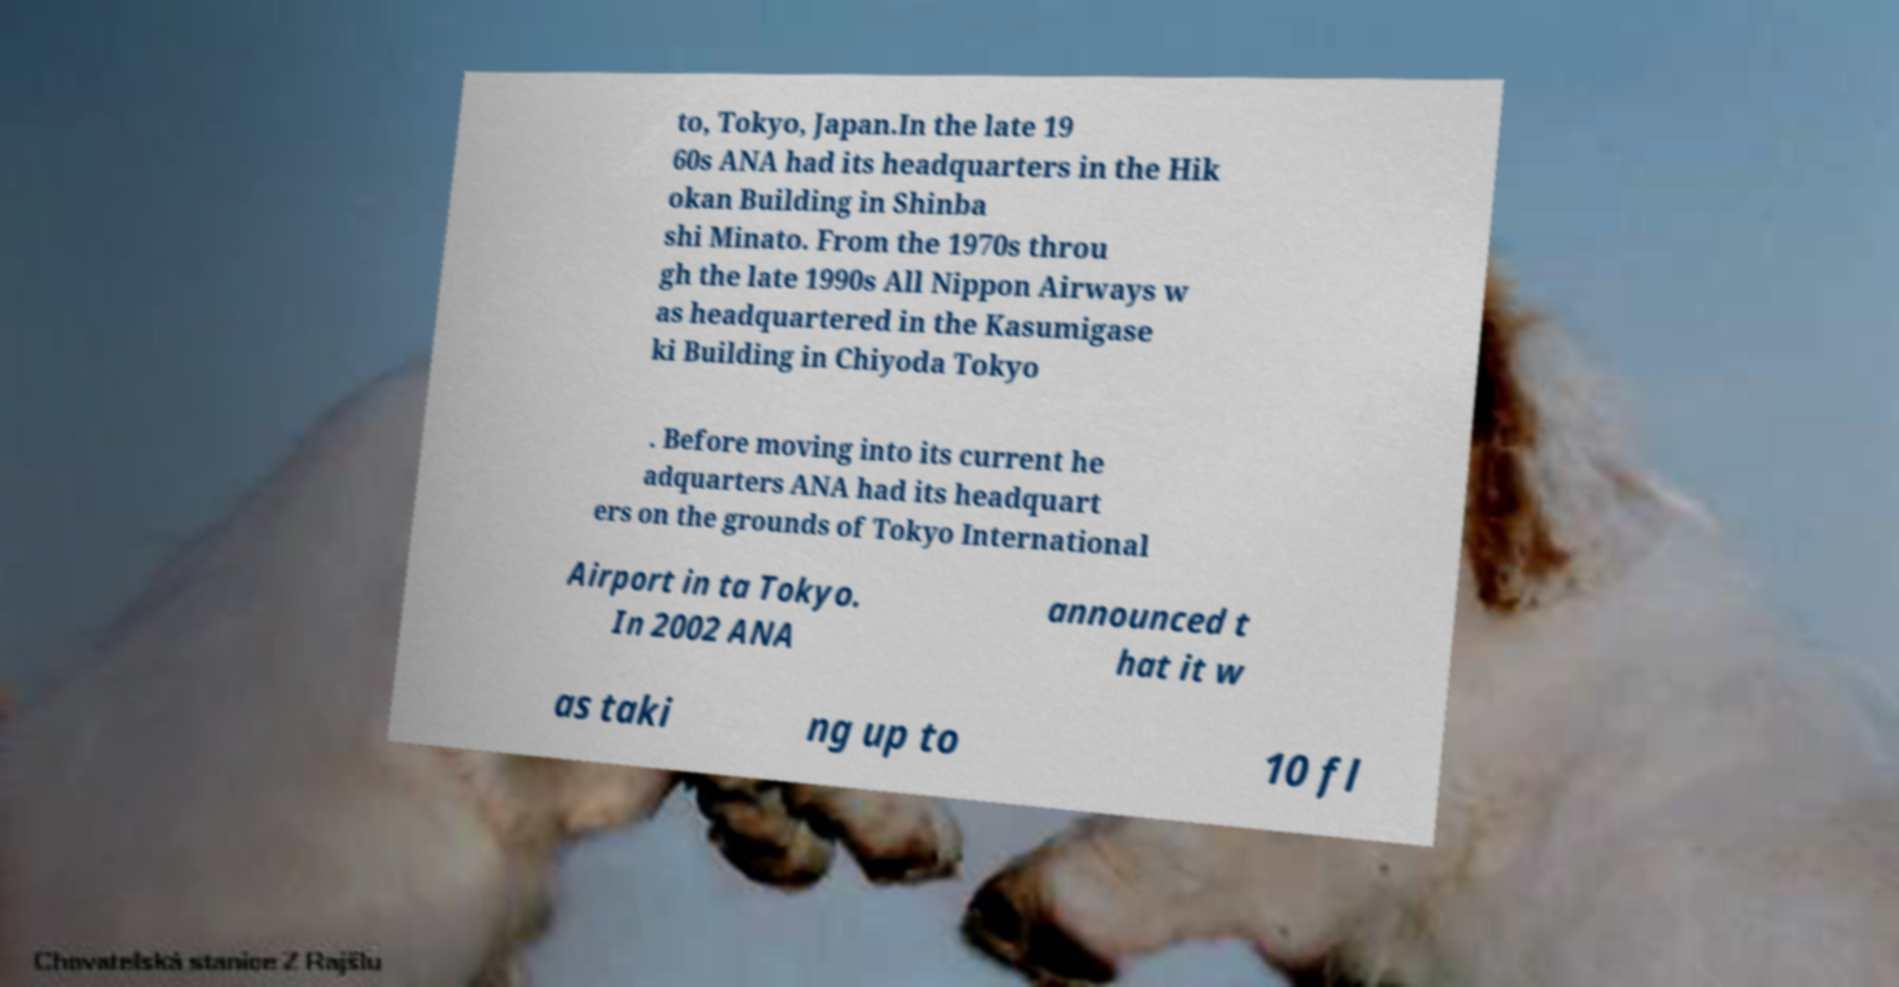What messages or text are displayed in this image? I need them in a readable, typed format. to, Tokyo, Japan.In the late 19 60s ANA had its headquarters in the Hik okan Building in Shinba shi Minato. From the 1970s throu gh the late 1990s All Nippon Airways w as headquartered in the Kasumigase ki Building in Chiyoda Tokyo . Before moving into its current he adquarters ANA had its headquart ers on the grounds of Tokyo International Airport in ta Tokyo. In 2002 ANA announced t hat it w as taki ng up to 10 fl 